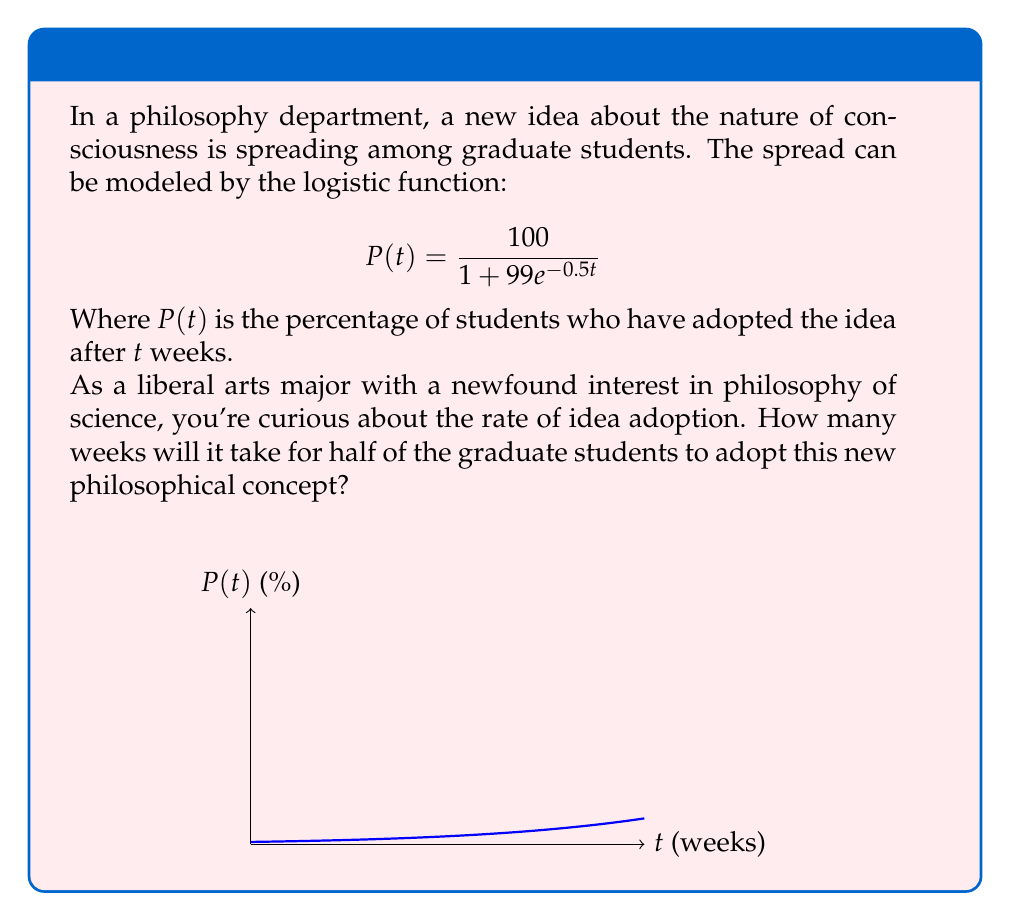Give your solution to this math problem. Let's approach this step-by-step:

1) We're looking for the time $t$ when $P(t) = 50$, as this represents half of the students (50%).

2) We can set up the equation:

   $$50 = \frac{100}{1 + 99e^{-0.5t}}$$

3) Multiply both sides by $(1 + 99e^{-0.5t})$:

   $$50(1 + 99e^{-0.5t}) = 100$$

4) Distribute on the left side:

   $$50 + 4950e^{-0.5t} = 100$$

5) Subtract 50 from both sides:

   $$4950e^{-0.5t} = 50$$

6) Divide both sides by 4950:

   $$e^{-0.5t} = \frac{1}{99}$$

7) Take the natural log of both sides:

   $$-0.5t = \ln(\frac{1}{99})$$

8) Multiply both sides by -2:

   $$t = -2\ln(\frac{1}{99})$$

9) Simplify:

   $$t = 2\ln(99) \approx 9.19$$

Therefore, it will take approximately 9.19 weeks for half of the graduate students to adopt the new philosophical concept.
Answer: $2\ln(99) \approx 9.19$ weeks 